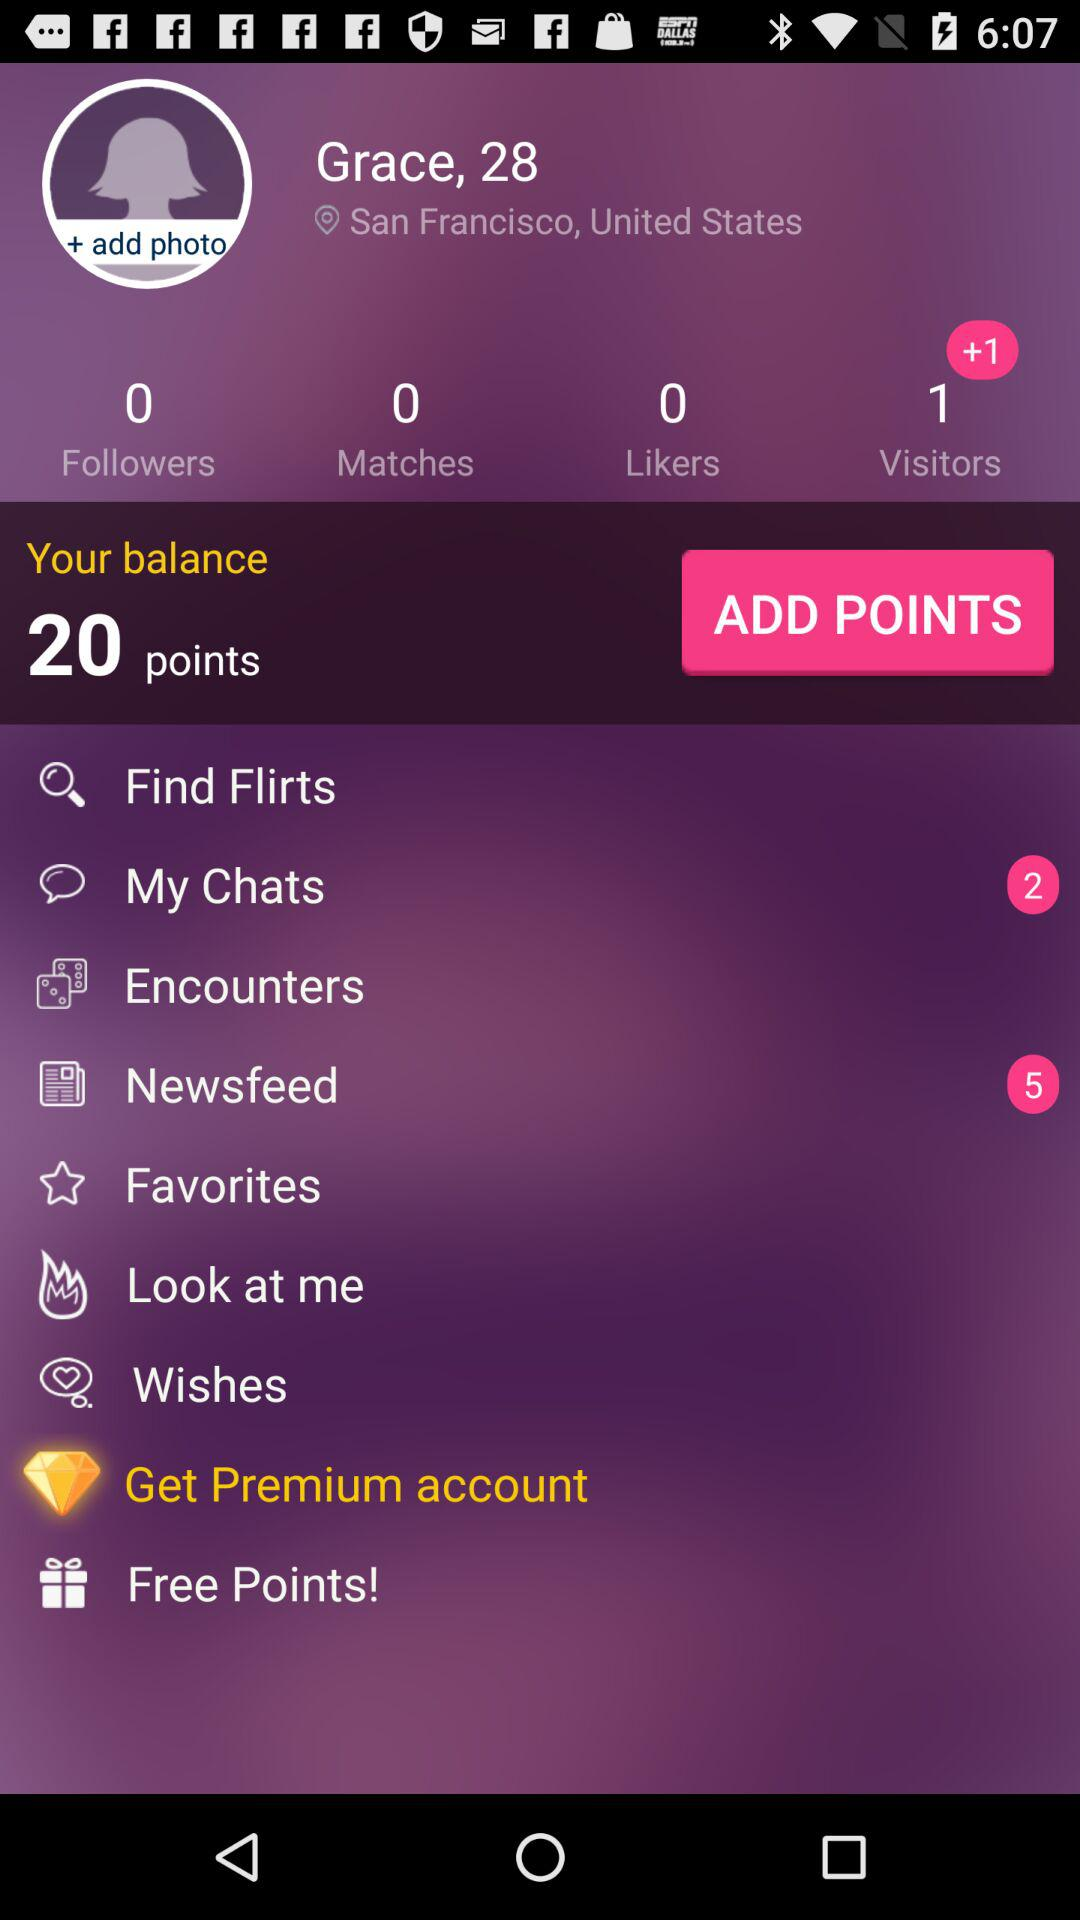What's the total number of followers? The total number of followers is 0. 